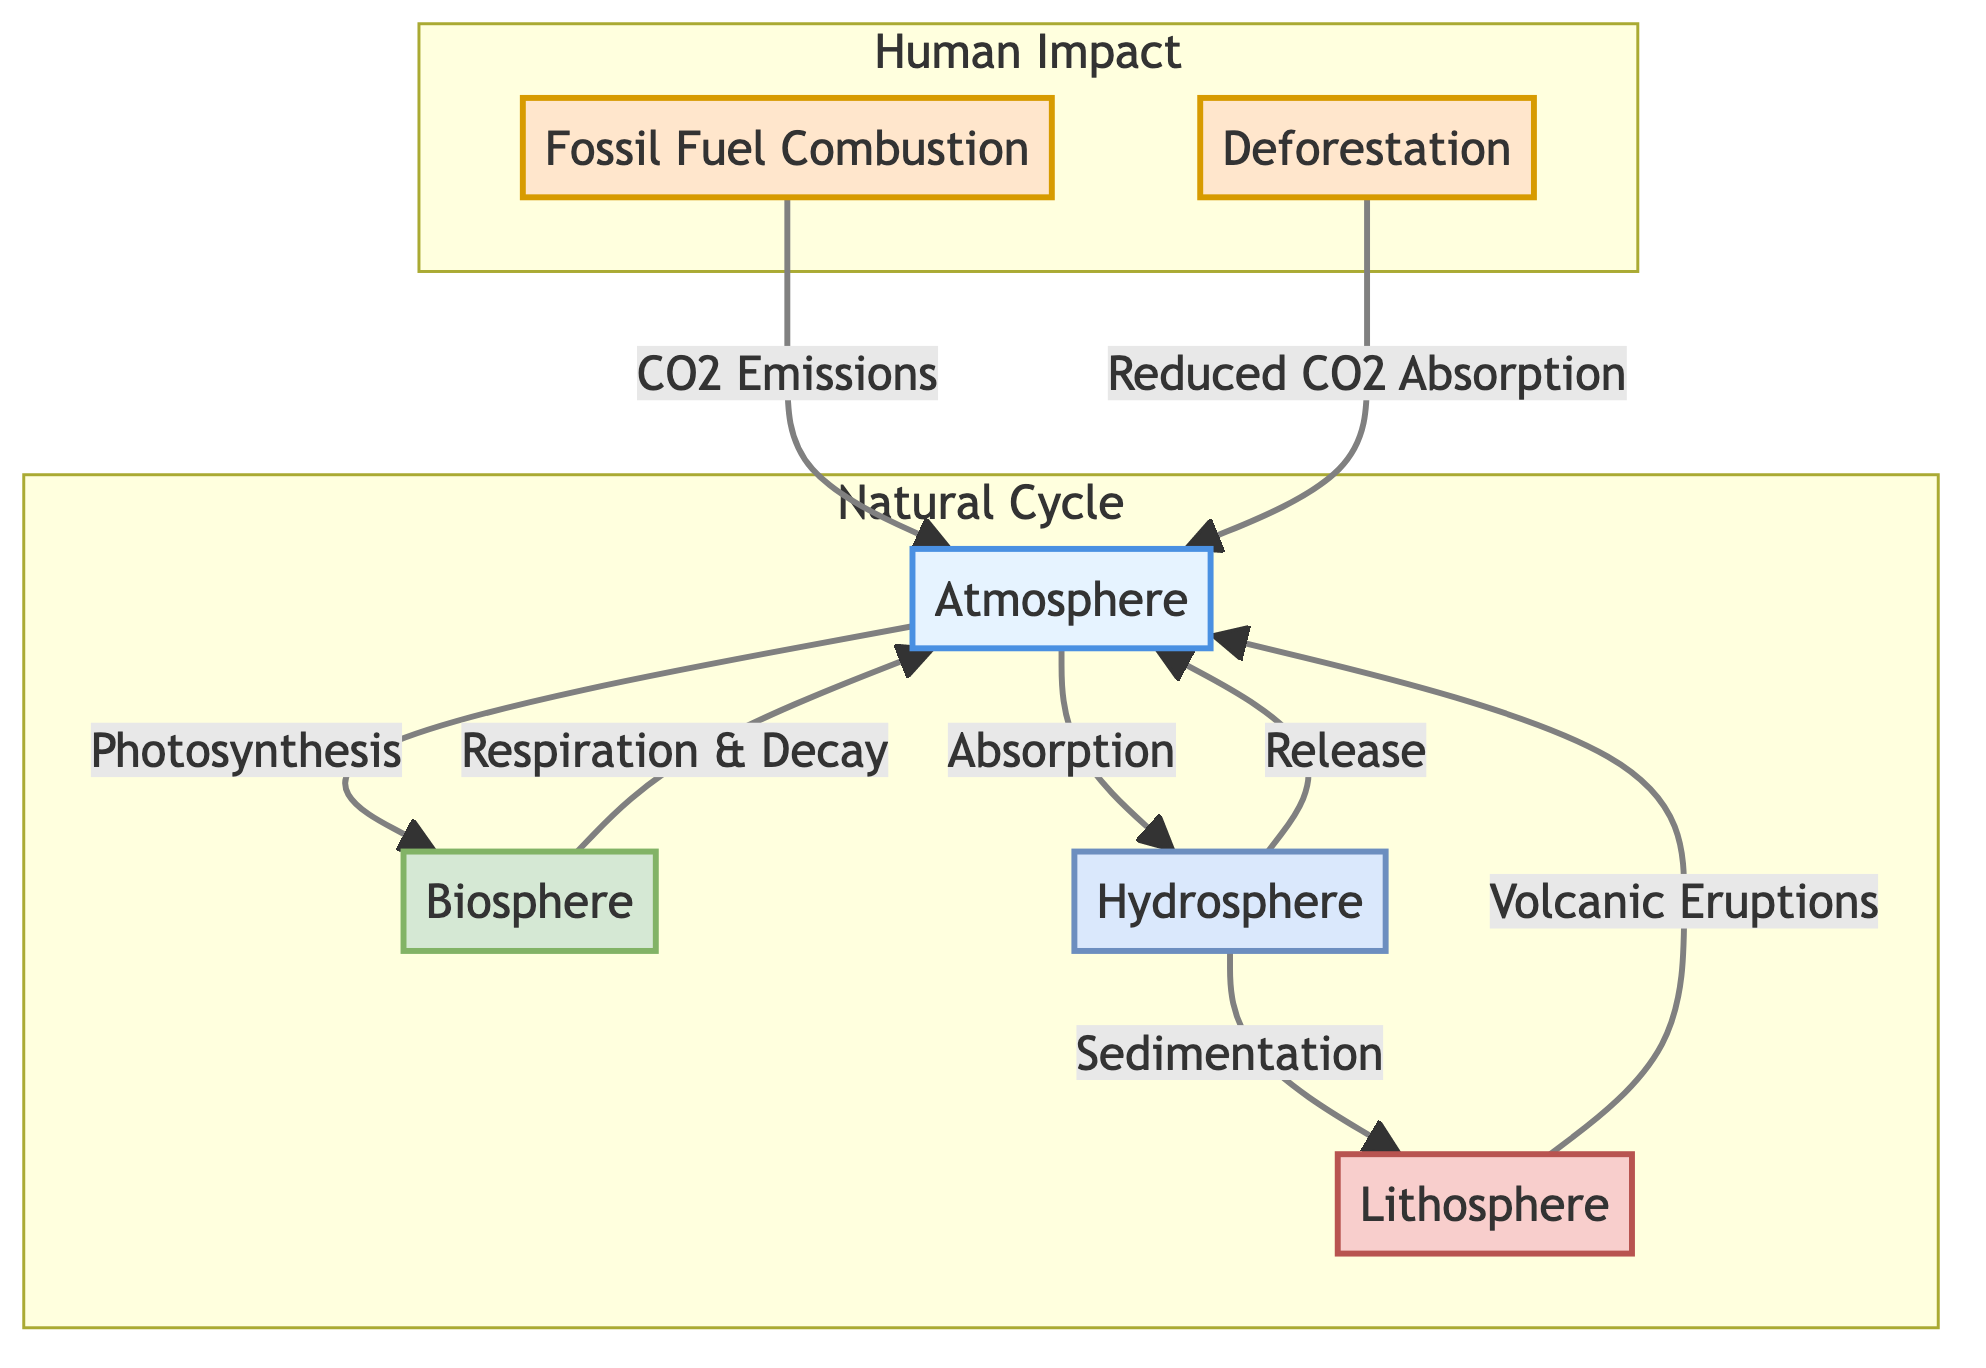What are the two main components of the carbon cycle depicted in the diagram? The diagram shows the main components as the Atmosphere and the Biosphere, which are highlighted as separate nodes and involved in carbon flow through processes like photosynthesis and respiration.
Answer: Atmosphere, Biosphere How does carbon move from the biosphere back to the atmosphere? The flow from the Biosphere to the Atmosphere is represented as "Respiration & Decay," indicating that carbon is released back into the atmosphere through these processes.
Answer: Respiration & Decay What anthropogenic factor is associated with CO2 emissions in the diagram? The diagram identifies "Fossil Fuel Combustion" as the anthropogenic factor linked to CO2 emissions, which directly shows the impact on the Atmosphere.
Answer: Fossil Fuel Combustion How many processes connect the atmosphere and hydrosphere? The diagram visually shows two connecting processes: "Absorption" from the Atmosphere to the Hydrosphere and "Release" from the Hydrosphere back to the Atmosphere, leading to a count of two processes.
Answer: 2 What impacts does deforestation have according to the diagram? In the diagram, deforestation is said to have the effect of "Reduced CO2 Absorption," indicating its negative impact on the carbon cycle as it reduces the ability of the atmosphere to absorb carbon dioxide.
Answer: Reduced CO2 Absorption Which natural cycle component releases carbon back to the atmosphere through volcanic eruptions? The Lithosphere is depicted in the diagram as releasing carbon back into the atmosphere through the process labeled "Volcanic Eruptions," highlighting its role in the natural carbon cycle.
Answer: Lithosphere What role does the hydrosphere play in the carbon cycle? The Hydrosphere is indicated to absorb carbon from the atmosphere and also to release it back, showing its dual role in the carbon cycle as a storage and release system for carbon.
Answer: Absorption and Release What is the implication of the human impact section on the natural cycle? The human impact section demonstrates how factors like fossil fuel combustion and deforestation disrupt the natural carbon cycle by contributing additional CO2 to the atmosphere and reducing natural carbon sinks.
Answer: Disruption of the natural carbon cycle 